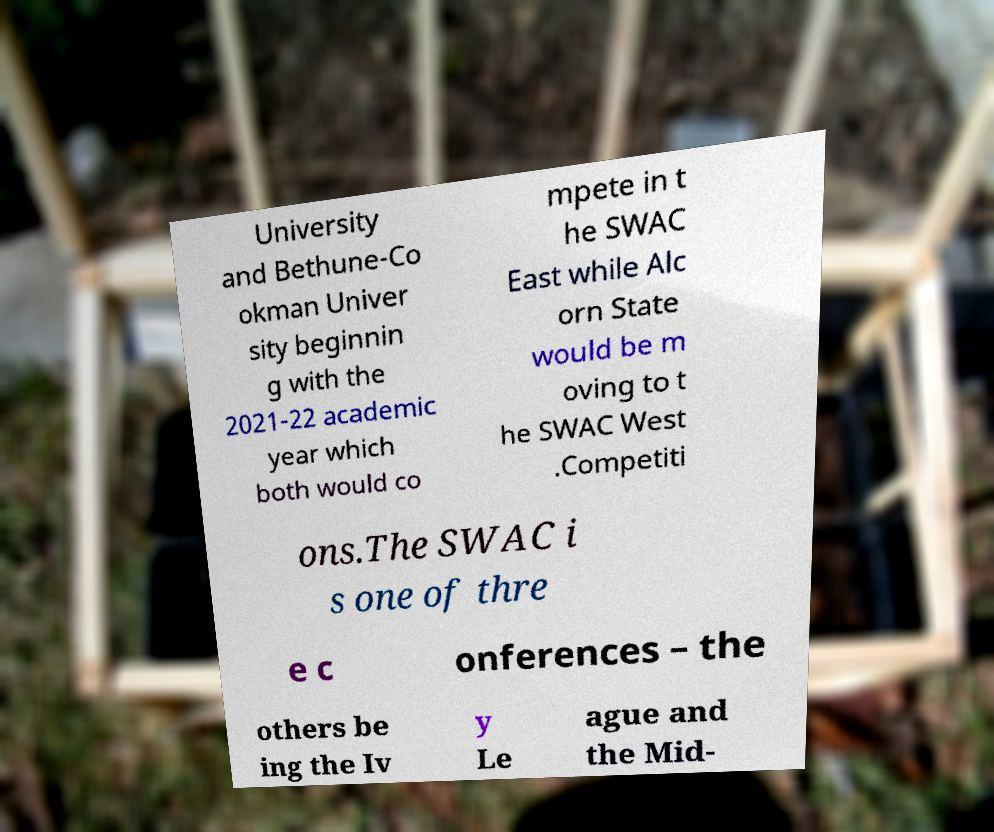Could you assist in decoding the text presented in this image and type it out clearly? University and Bethune-Co okman Univer sity beginnin g with the 2021-22 academic year which both would co mpete in t he SWAC East while Alc orn State would be m oving to t he SWAC West .Competiti ons.The SWAC i s one of thre e c onferences – the others be ing the Iv y Le ague and the Mid- 